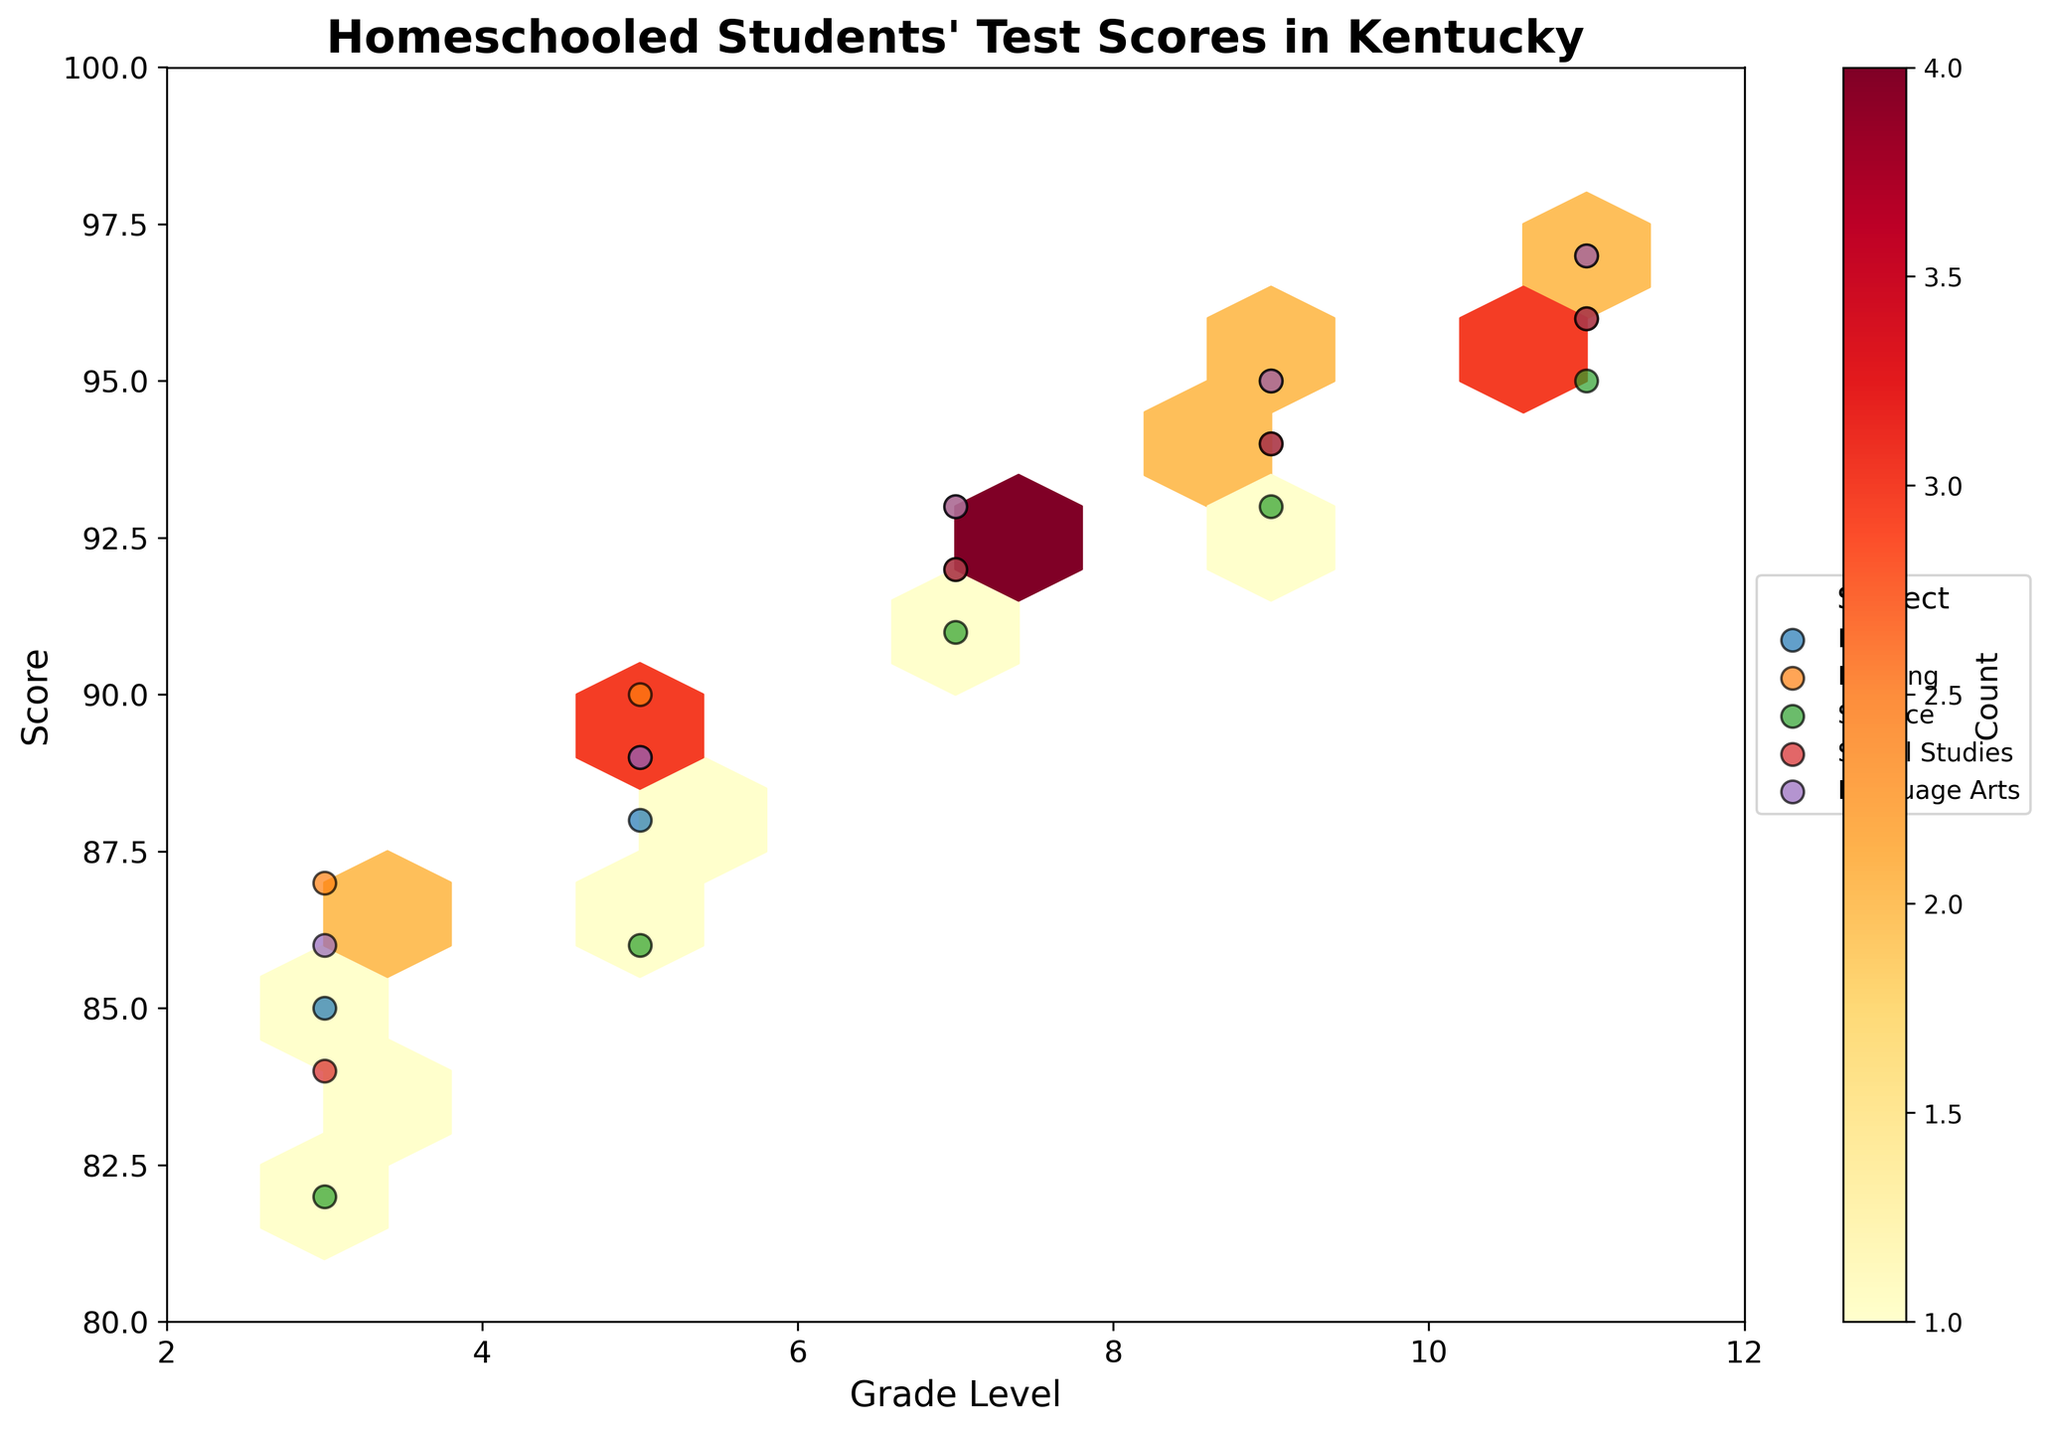What is the title of the hexbin plot? The title of the plot is typically found at the top. In this case, it reads "Homeschooled Students' Test Scores in Kentucky".
Answer: Homeschooled Students' Test Scores in Kentucky What are the axes labels of the plot? The axes labels can be identified by looking at the text next to the x-axis and y-axis. Here, the x-axis label is "Grade Level" and the y-axis label is "Score".
Answer: Grade Level, Score Which subject has a score of 85 for 3rd grade? By locating the points on the plot and checking the labels, we can see that the subject with a score of 85 for 3rd grade is Math.
Answer: Math Between which grade levels are the homeschooled students' scores shown? The x-axis represents the grade levels, and in this plot, the values range from grades 3 to 11. By observing the range, we see it ends at 11.
Answer: 3 to 11 Which subject has the highest score for 11th grade? By examining the points for 11th grade along the y-axis and checking the labels, Reading and Language Arts both have the highest score, which is 97.
Answer: Reading, Language Arts In which grade do students have the lowest math score? Viewing the points for Math on the plot along the y-axis, the lowest score can be seen at the 3rd-grade level with a score of 85.
Answer: 3rd grade Which subject's scores appear to have the lowest overall concentration in the plot? Looking at the density of the scores on the plot, Science scores appear less concentrated compared to others.
Answer: Science What is the range of scores for Social Studies across all grade levels? Observing the points for Social Studies on the y-axis, the range of scores spans from the lowest in 3rd grade at 84 to the highest in 11th grade at 96.
Answer: 84 to 96 Which grade has the highest overall concentration of high scores? Viewing the hexbin plot's color density, the highest concentration of high scores appears in the 11th grade, as indicated by a denser cluster in the top section of the plot.
Answer: 11th grade Do scores generally increase, decrease, or stay the same as students progress to higher grades across all subjects? Observing the trend of points for each subject, scores seem to generally increase as the grade level increases.
Answer: Increase 